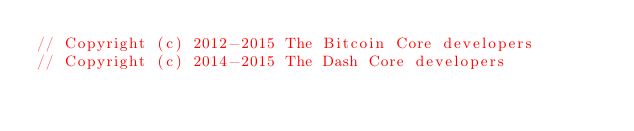Convert code to text. <code><loc_0><loc_0><loc_500><loc_500><_C++_>// Copyright (c) 2012-2015 The Bitcoin Core developers
// Copyright (c) 2014-2015 The Dash Core developers</code> 